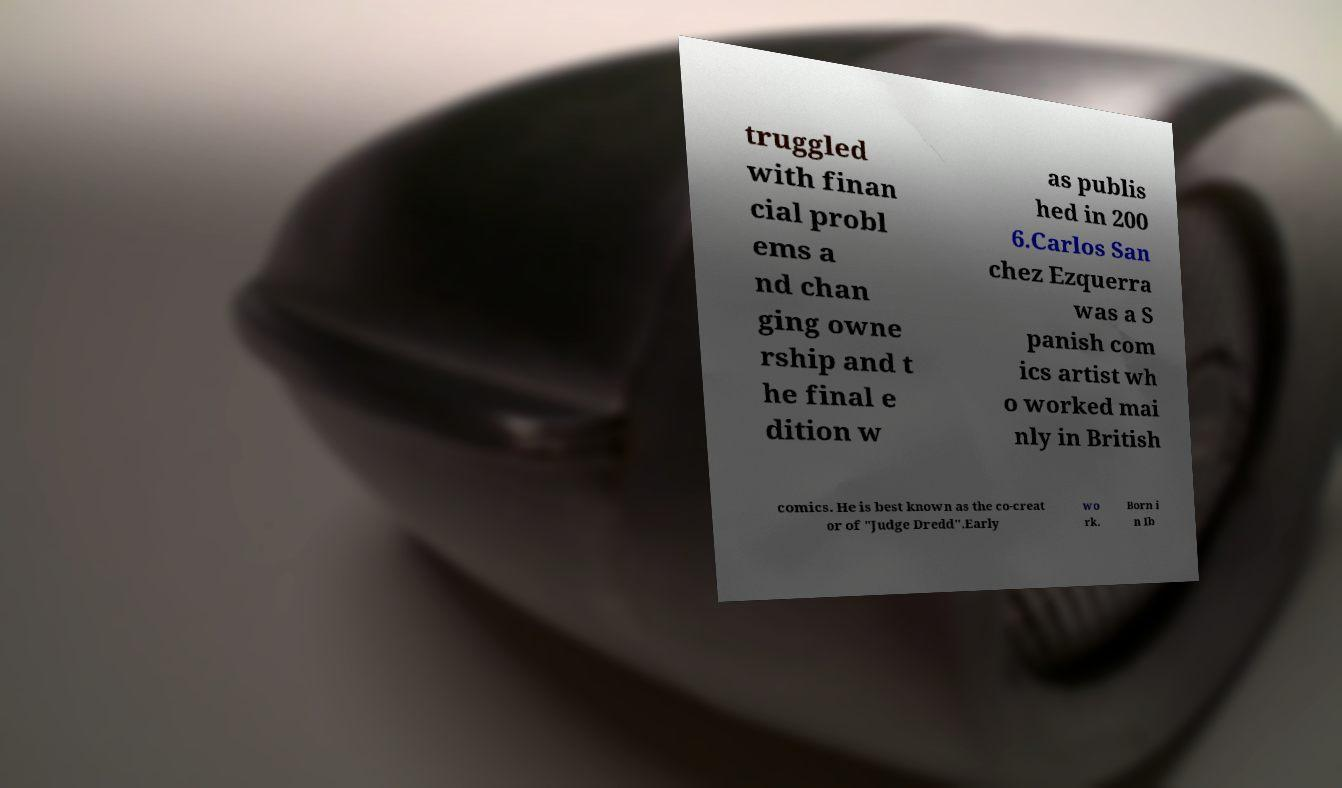Could you extract and type out the text from this image? truggled with finan cial probl ems a nd chan ging owne rship and t he final e dition w as publis hed in 200 6.Carlos San chez Ezquerra was a S panish com ics artist wh o worked mai nly in British comics. He is best known as the co-creat or of "Judge Dredd".Early wo rk. Born i n Ib 